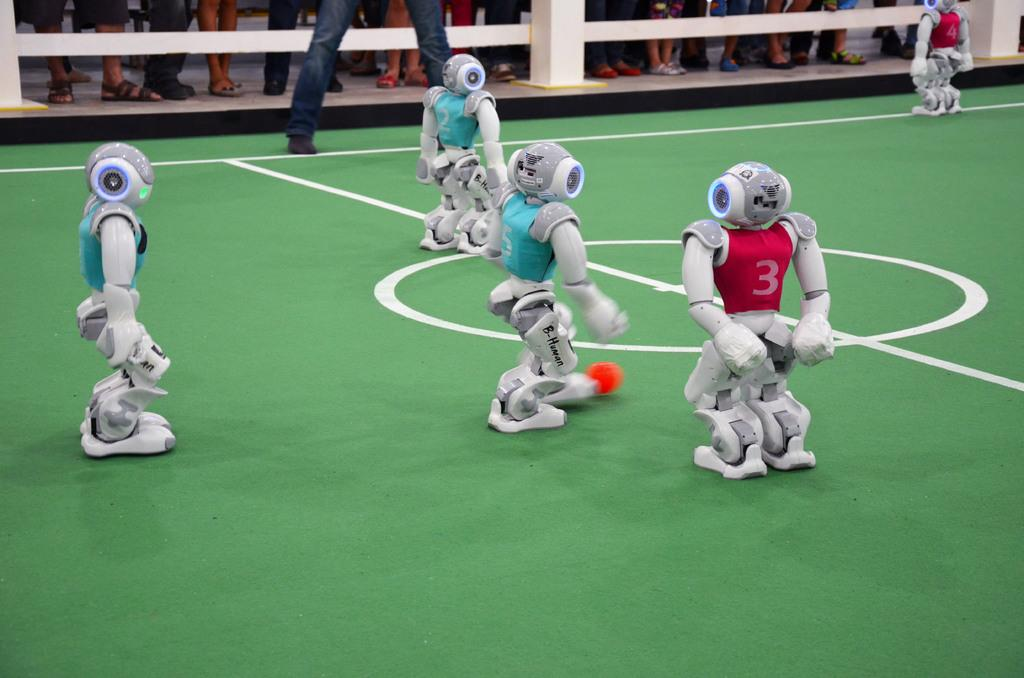<image>
Create a compact narrative representing the image presented. Robots playing a sport with one wearing a red jersey with the number 3. 